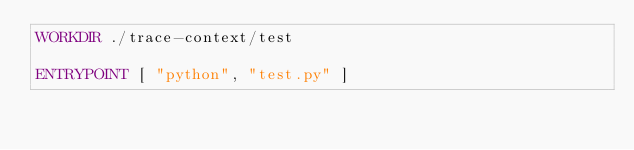<code> <loc_0><loc_0><loc_500><loc_500><_Dockerfile_>WORKDIR ./trace-context/test

ENTRYPOINT [ "python", "test.py" ]
</code> 